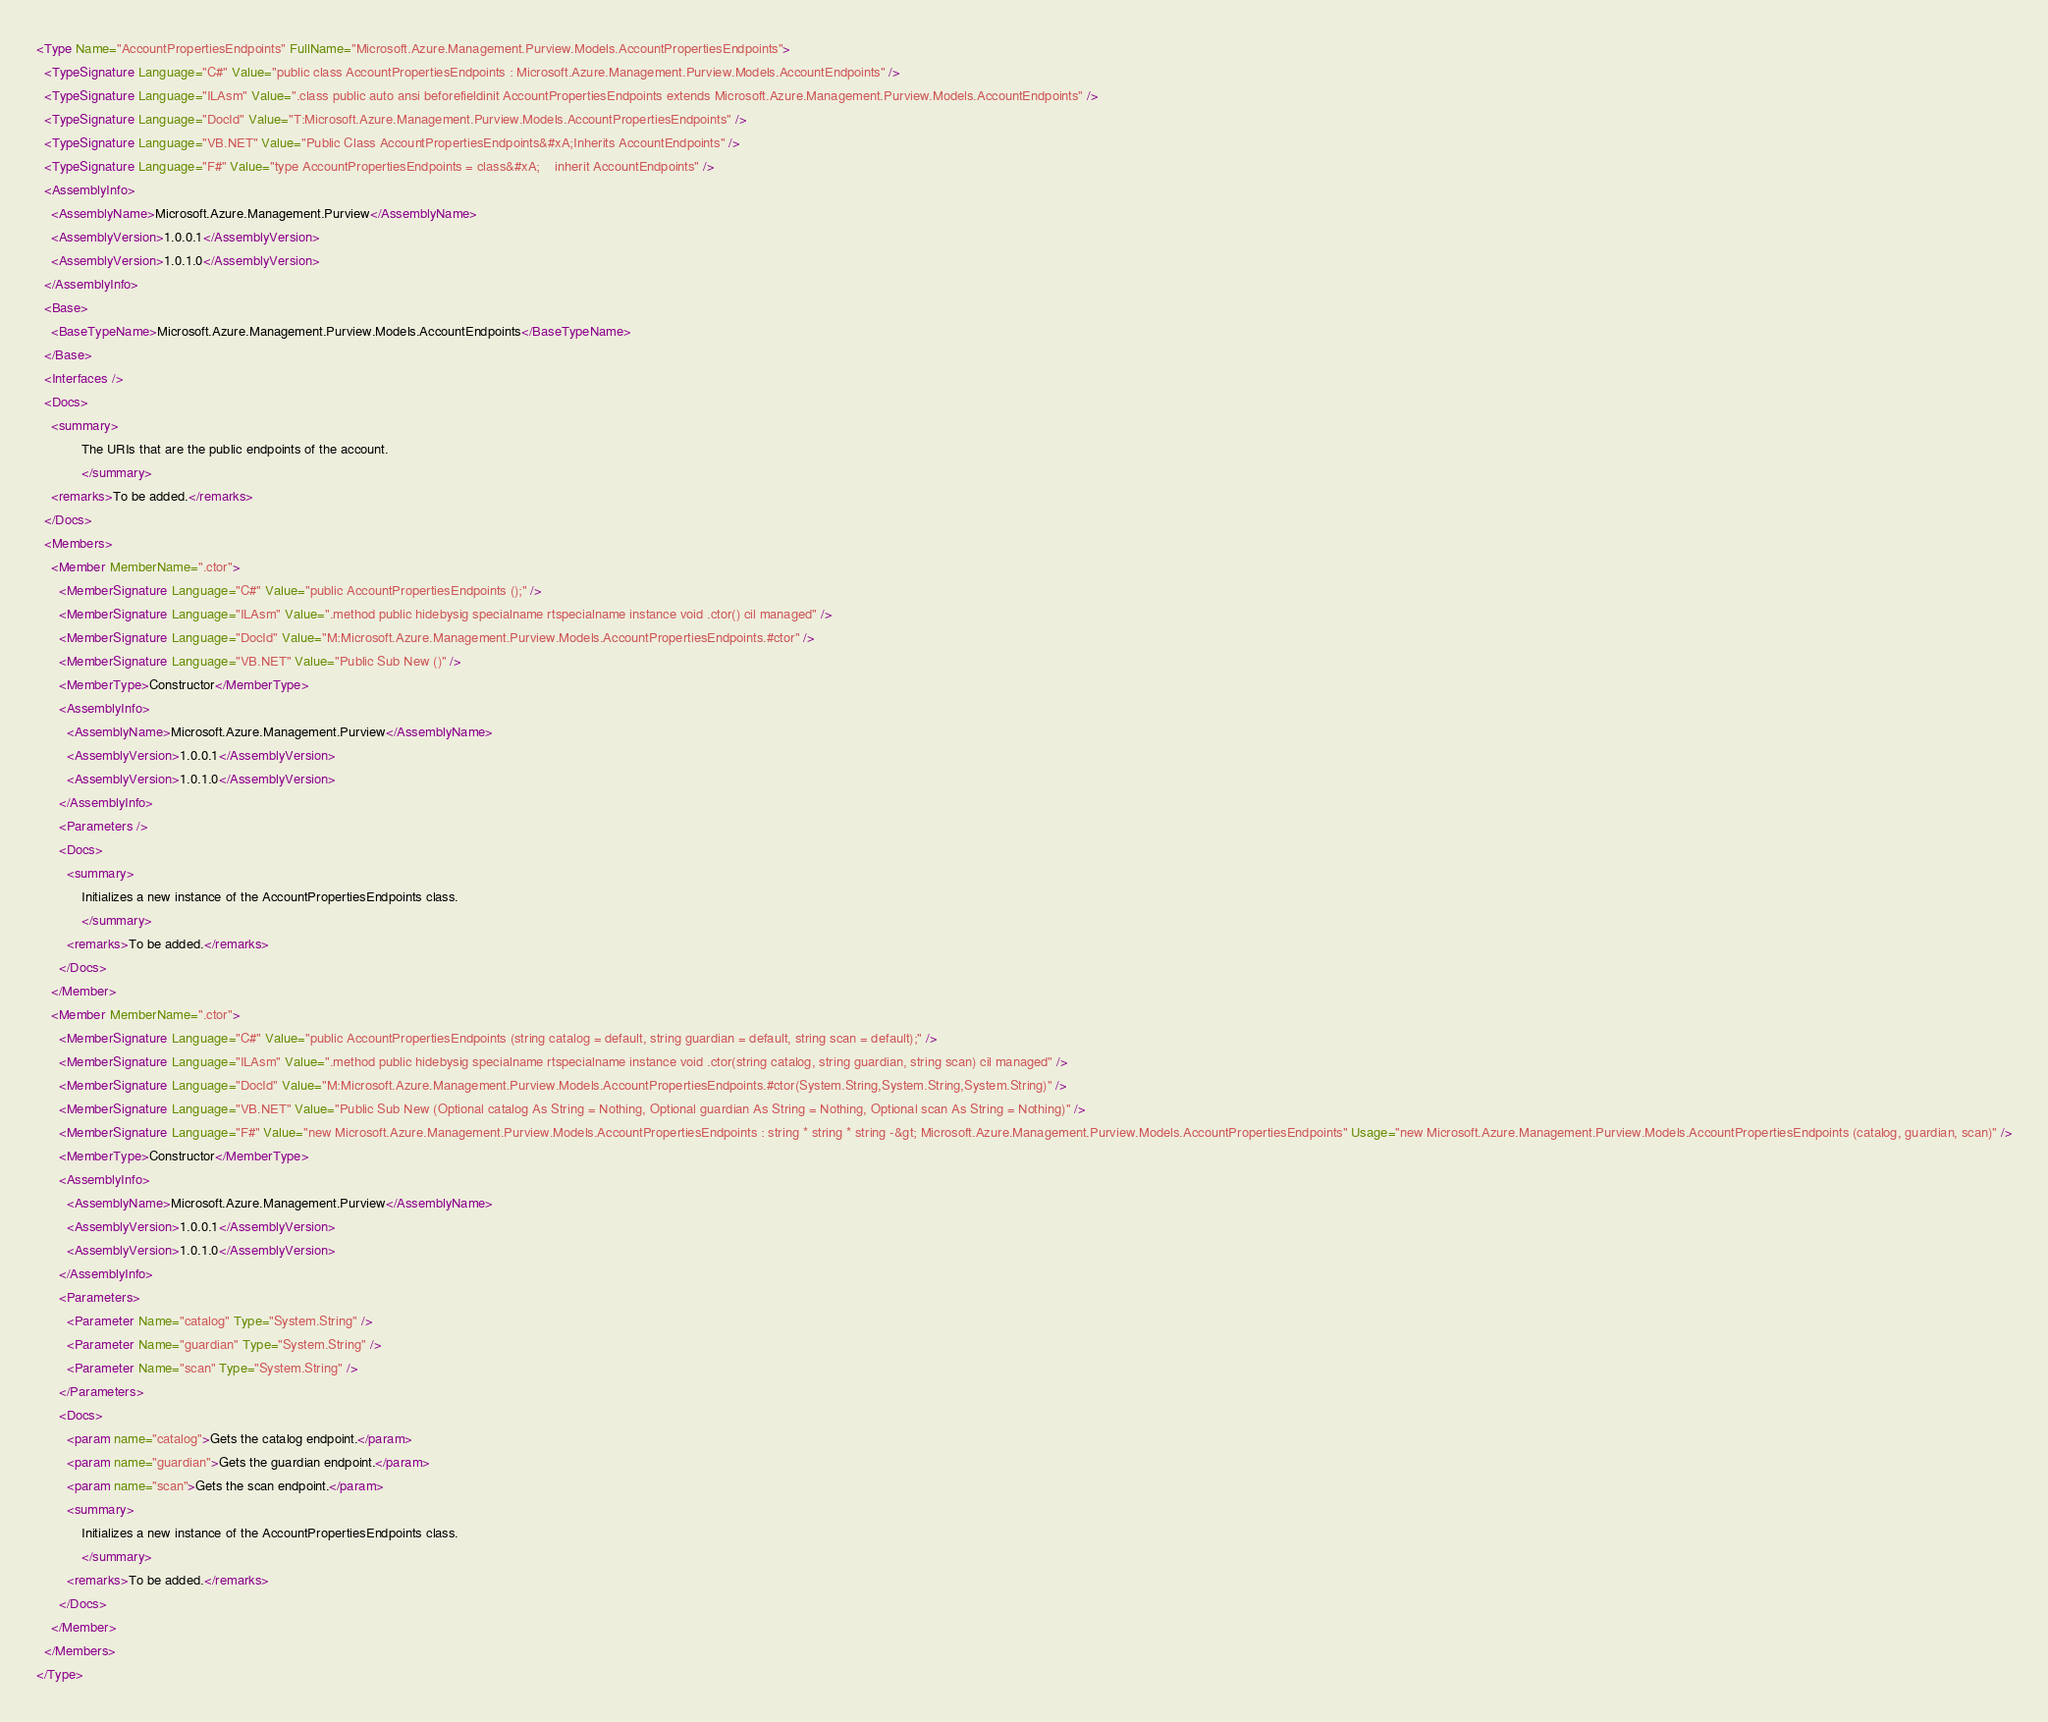<code> <loc_0><loc_0><loc_500><loc_500><_XML_><Type Name="AccountPropertiesEndpoints" FullName="Microsoft.Azure.Management.Purview.Models.AccountPropertiesEndpoints">
  <TypeSignature Language="C#" Value="public class AccountPropertiesEndpoints : Microsoft.Azure.Management.Purview.Models.AccountEndpoints" />
  <TypeSignature Language="ILAsm" Value=".class public auto ansi beforefieldinit AccountPropertiesEndpoints extends Microsoft.Azure.Management.Purview.Models.AccountEndpoints" />
  <TypeSignature Language="DocId" Value="T:Microsoft.Azure.Management.Purview.Models.AccountPropertiesEndpoints" />
  <TypeSignature Language="VB.NET" Value="Public Class AccountPropertiesEndpoints&#xA;Inherits AccountEndpoints" />
  <TypeSignature Language="F#" Value="type AccountPropertiesEndpoints = class&#xA;    inherit AccountEndpoints" />
  <AssemblyInfo>
    <AssemblyName>Microsoft.Azure.Management.Purview</AssemblyName>
    <AssemblyVersion>1.0.0.1</AssemblyVersion>
    <AssemblyVersion>1.0.1.0</AssemblyVersion>
  </AssemblyInfo>
  <Base>
    <BaseTypeName>Microsoft.Azure.Management.Purview.Models.AccountEndpoints</BaseTypeName>
  </Base>
  <Interfaces />
  <Docs>
    <summary>
            The URIs that are the public endpoints of the account.
            </summary>
    <remarks>To be added.</remarks>
  </Docs>
  <Members>
    <Member MemberName=".ctor">
      <MemberSignature Language="C#" Value="public AccountPropertiesEndpoints ();" />
      <MemberSignature Language="ILAsm" Value=".method public hidebysig specialname rtspecialname instance void .ctor() cil managed" />
      <MemberSignature Language="DocId" Value="M:Microsoft.Azure.Management.Purview.Models.AccountPropertiesEndpoints.#ctor" />
      <MemberSignature Language="VB.NET" Value="Public Sub New ()" />
      <MemberType>Constructor</MemberType>
      <AssemblyInfo>
        <AssemblyName>Microsoft.Azure.Management.Purview</AssemblyName>
        <AssemblyVersion>1.0.0.1</AssemblyVersion>
        <AssemblyVersion>1.0.1.0</AssemblyVersion>
      </AssemblyInfo>
      <Parameters />
      <Docs>
        <summary>
            Initializes a new instance of the AccountPropertiesEndpoints class.
            </summary>
        <remarks>To be added.</remarks>
      </Docs>
    </Member>
    <Member MemberName=".ctor">
      <MemberSignature Language="C#" Value="public AccountPropertiesEndpoints (string catalog = default, string guardian = default, string scan = default);" />
      <MemberSignature Language="ILAsm" Value=".method public hidebysig specialname rtspecialname instance void .ctor(string catalog, string guardian, string scan) cil managed" />
      <MemberSignature Language="DocId" Value="M:Microsoft.Azure.Management.Purview.Models.AccountPropertiesEndpoints.#ctor(System.String,System.String,System.String)" />
      <MemberSignature Language="VB.NET" Value="Public Sub New (Optional catalog As String = Nothing, Optional guardian As String = Nothing, Optional scan As String = Nothing)" />
      <MemberSignature Language="F#" Value="new Microsoft.Azure.Management.Purview.Models.AccountPropertiesEndpoints : string * string * string -&gt; Microsoft.Azure.Management.Purview.Models.AccountPropertiesEndpoints" Usage="new Microsoft.Azure.Management.Purview.Models.AccountPropertiesEndpoints (catalog, guardian, scan)" />
      <MemberType>Constructor</MemberType>
      <AssemblyInfo>
        <AssemblyName>Microsoft.Azure.Management.Purview</AssemblyName>
        <AssemblyVersion>1.0.0.1</AssemblyVersion>
        <AssemblyVersion>1.0.1.0</AssemblyVersion>
      </AssemblyInfo>
      <Parameters>
        <Parameter Name="catalog" Type="System.String" />
        <Parameter Name="guardian" Type="System.String" />
        <Parameter Name="scan" Type="System.String" />
      </Parameters>
      <Docs>
        <param name="catalog">Gets the catalog endpoint.</param>
        <param name="guardian">Gets the guardian endpoint.</param>
        <param name="scan">Gets the scan endpoint.</param>
        <summary>
            Initializes a new instance of the AccountPropertiesEndpoints class.
            </summary>
        <remarks>To be added.</remarks>
      </Docs>
    </Member>
  </Members>
</Type>
</code> 